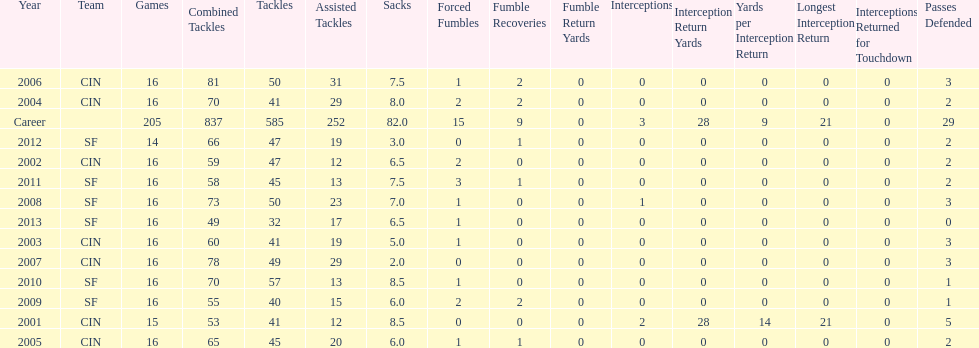How many fumble recoveries did this player have in 2004? 2. 